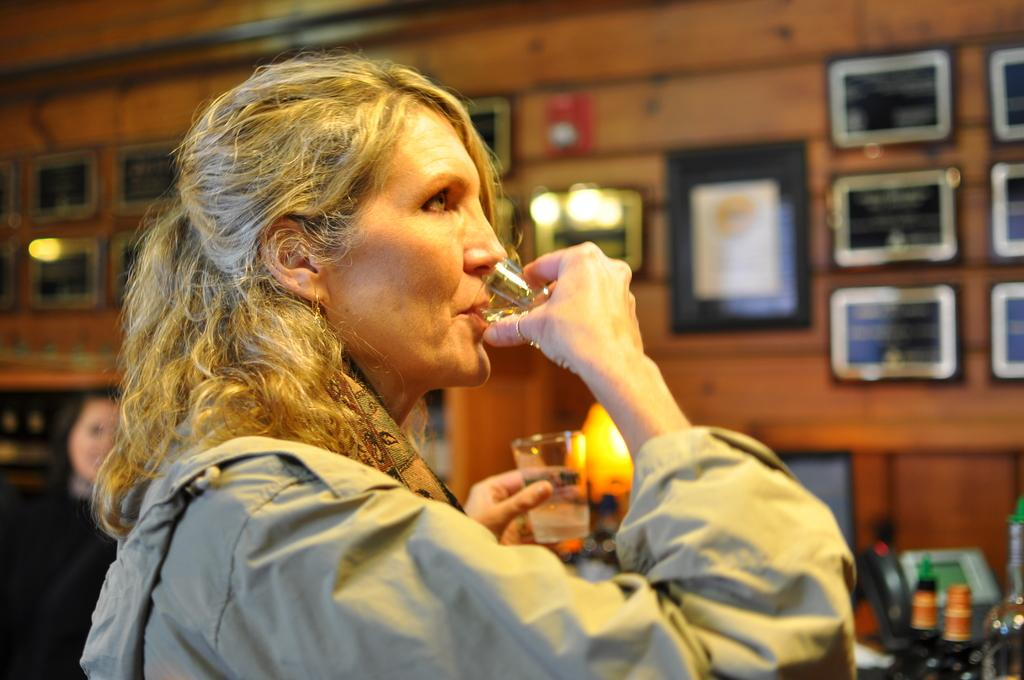What is the person in the image doing? The person in the image is drinking. What is the person holding in her hand? The person is holding a glass in her hand. What can be seen on the wall behind her? There are many photo frames on the wall behind her. What type of apple can be seen in the image? There is no apple present in the image. What type of juice is being consumed in the image? The image does not specify the type of liquid being consumed, only that the person is drinking. 